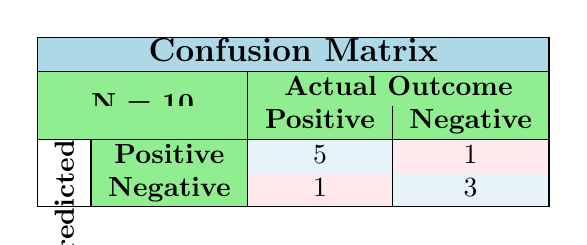What is the total number of students whose behavior improved to positive after the program? Looking at the table, there are 5 students predicted to have a positive outcome (indicated in the first row) and 1 student with a negative predicted outcome (cell in the second row), making a total of 5 students with a positive outcome.
Answer: 5 How many students maintained calm behavior before and after the program? There are 2 students, student_id 4 and student_id 10, highlighted in the table with both pre and post program behavior as calm.
Answer: 2 What is the number of students whose predicted outcome was negative? In the table, there are 1 student predicted as negative with positive behavior and 3 students predicted as negative with negative behavior, totaling 4 students with negative predicted outcomes.
Answer: 4 True or False: More students showed improvement to calm behavior than those who remained aggressive. From the table, 5 students improved to calm behavior while 4 students remained aggressive, thus confirming this statement is true.
Answer: True What is the difference in the number of students between those who had a positive outcome and those with a negative outcome? The table indicates 6 students had a positive outcome (5 from first row + 1 from second row) while 4 showed a negative outcome. The difference is 6 - 4 = 2.
Answer: 2 How many students started with an aggressive behavior but still had a negative outcome? Referring to the table, only 1 student started as aggressive (student_id 3) and remained so, hence there is only 1 student fitting this description.
Answer: 1 What percentage of students showed a positive outcome? There are 6 students with a positive predicted outcome out of 10 total students, which translates to (6/10) * 100 = 60%.
Answer: 60% What is the total number of students whose behavior did not change or worsened after the program? From the table, 1 student showed no change (stayed aggressive) and 3 students displayed worsened behavior (remained aggressive or turned aggressive), summing up to 4 students.
Answer: 4 How many students who were neutral before the program improved to positive behavior afterward? Looking at the table, 2 students who were neutral before the program (student_id 2 and student_id 9) improved to calm behavior, leading to the conclusion that 2 students achieved a positive outcome.
Answer: 2 